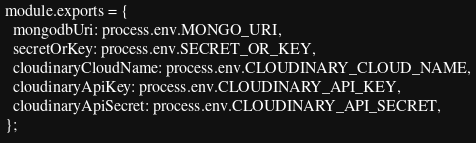Convert code to text. <code><loc_0><loc_0><loc_500><loc_500><_JavaScript_>module.exports = {
  mongodbUri: process.env.MONGO_URI,
  secretOrKey: process.env.SECRET_OR_KEY,
  cloudinaryCloudName: process.env.CLOUDINARY_CLOUD_NAME,
  cloudinaryApiKey: process.env.CLOUDINARY_API_KEY,
  cloudinaryApiSecret: process.env.CLOUDINARY_API_SECRET,
};
</code> 